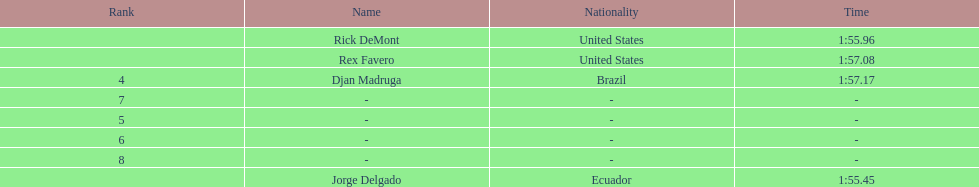What come after rex f. Djan Madruga. 